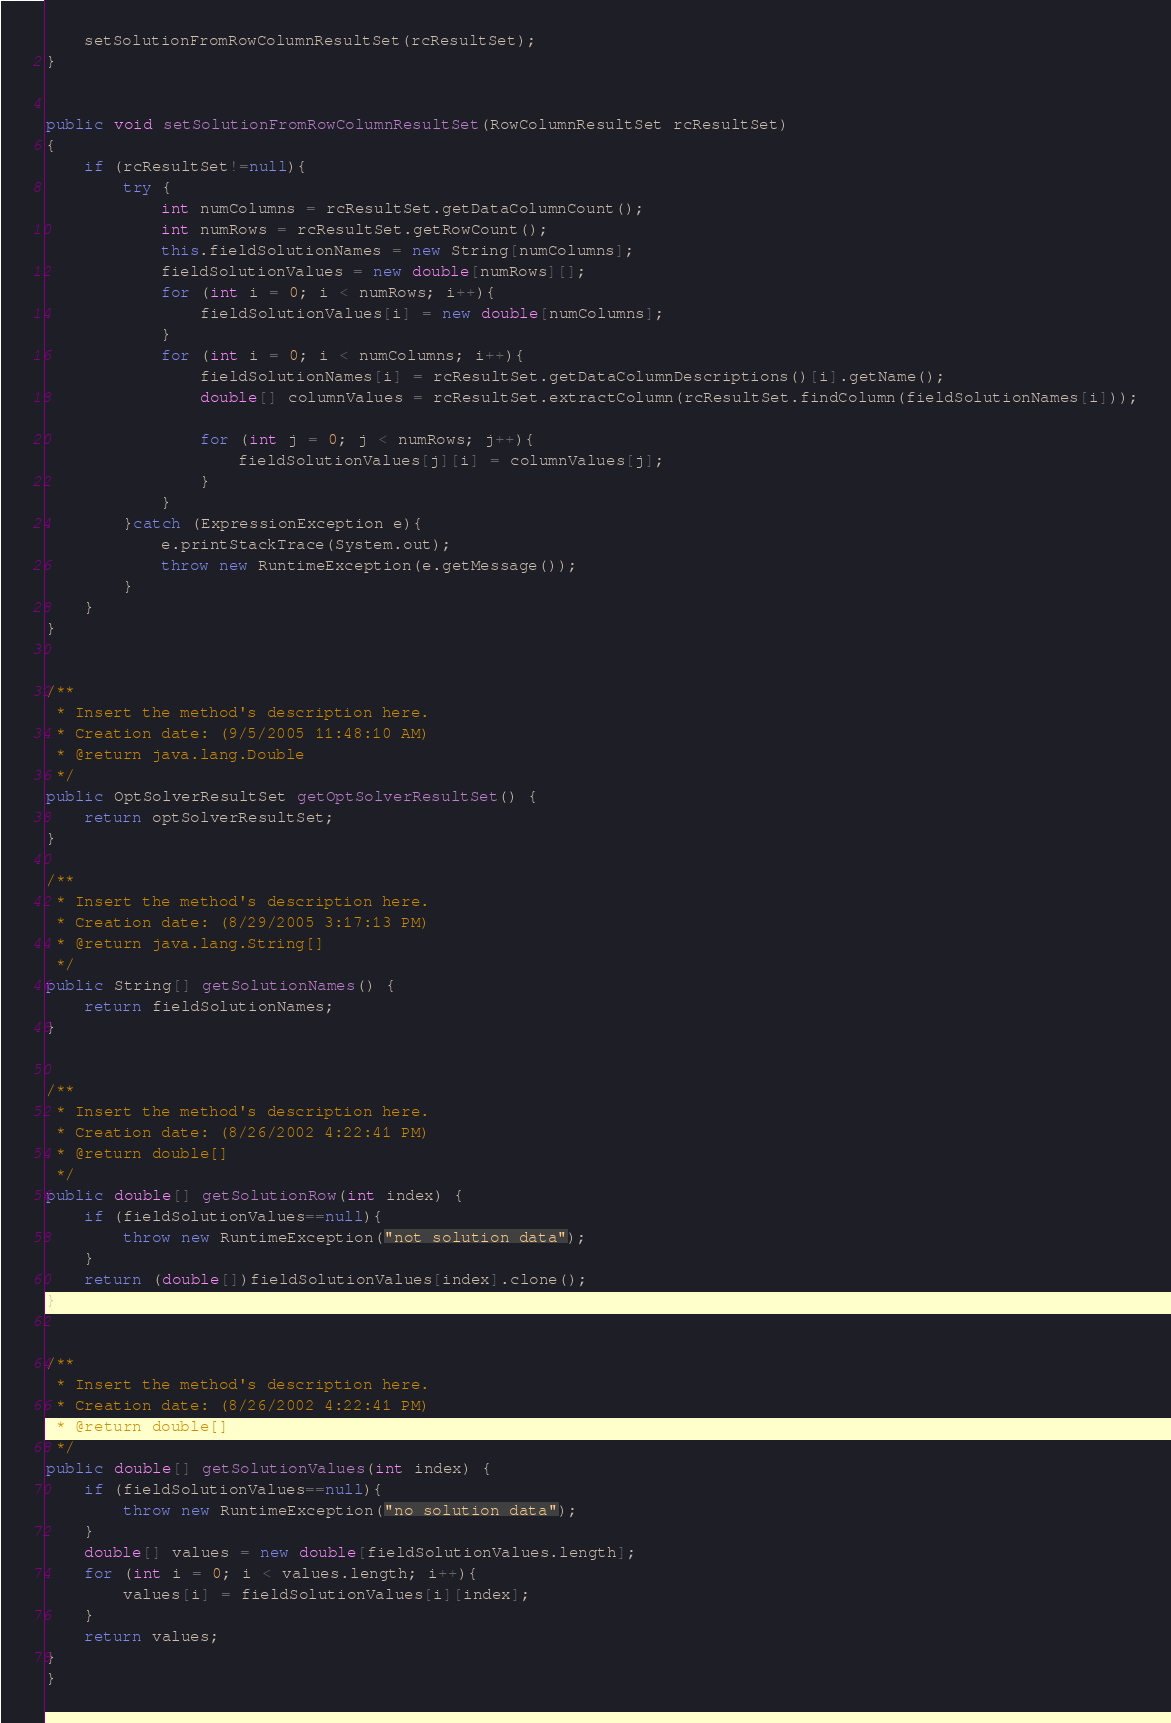Convert code to text. <code><loc_0><loc_0><loc_500><loc_500><_Java_>	setSolutionFromRowColumnResultSet(rcResultSet);
}


public void setSolutionFromRowColumnResultSet(RowColumnResultSet rcResultSet)
{
	if (rcResultSet!=null){
		try {
			int numColumns = rcResultSet.getDataColumnCount();
			int numRows = rcResultSet.getRowCount();
			this.fieldSolutionNames = new String[numColumns];
			fieldSolutionValues = new double[numRows][];
			for (int i = 0; i < numRows; i++){
				fieldSolutionValues[i] = new double[numColumns];
			}
			for (int i = 0; i < numColumns; i++){
				fieldSolutionNames[i] = rcResultSet.getDataColumnDescriptions()[i].getName();
				double[] columnValues = rcResultSet.extractColumn(rcResultSet.findColumn(fieldSolutionNames[i]));

				for (int j = 0; j < numRows; j++){
					fieldSolutionValues[j][i] = columnValues[j];
				}
			}
		}catch (ExpressionException e){
			e.printStackTrace(System.out);
			throw new RuntimeException(e.getMessage());
		}
	}
}


/**
 * Insert the method's description here.
 * Creation date: (9/5/2005 11:48:10 AM)
 * @return java.lang.Double
 */
public OptSolverResultSet getOptSolverResultSet() {
	return optSolverResultSet;
}

/**
 * Insert the method's description here.
 * Creation date: (8/29/2005 3:17:13 PM)
 * @return java.lang.String[]
 */
public String[] getSolutionNames() {
	return fieldSolutionNames;
}


/**
 * Insert the method's description here.
 * Creation date: (8/26/2002 4:22:41 PM)
 * @return double[]
 */
public double[] getSolutionRow(int index) {
	if (fieldSolutionValues==null){
		throw new RuntimeException("not solution data");
	}
	return (double[])fieldSolutionValues[index].clone();
}


/**
 * Insert the method's description here.
 * Creation date: (8/26/2002 4:22:41 PM)
 * @return double[]
 */
public double[] getSolutionValues(int index) {
	if (fieldSolutionValues==null){
		throw new RuntimeException("no solution data");
	}
	double[] values = new double[fieldSolutionValues.length];
	for (int i = 0; i < values.length; i++){
		values[i] = fieldSolutionValues[i][index];
	}
	return values;
}
}
</code> 